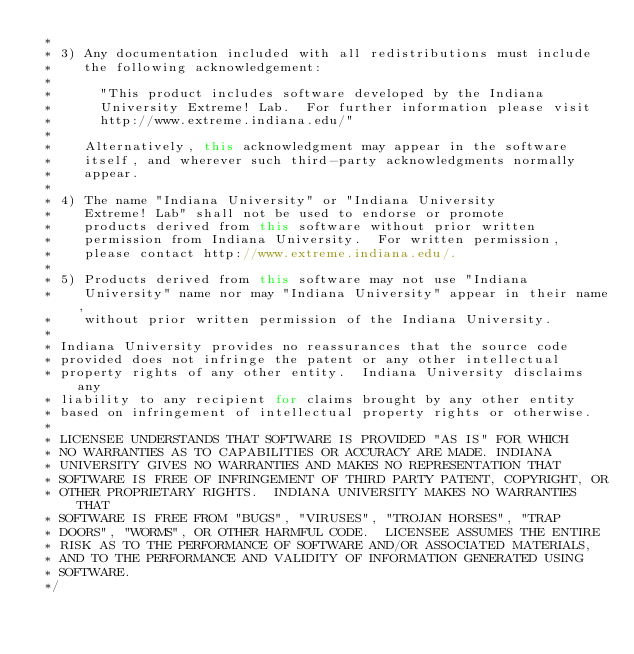Convert code to text. <code><loc_0><loc_0><loc_500><loc_500><_Java_> *
 * 3) Any documentation included with all redistributions must include
 *    the following acknowledgement:
 *
 *      "This product includes software developed by the Indiana
 *      University Extreme! Lab.  For further information please visit
 *      http://www.extreme.indiana.edu/"
 *
 *    Alternatively, this acknowledgment may appear in the software
 *    itself, and wherever such third-party acknowledgments normally
 *    appear.
 *
 * 4) The name "Indiana University" or "Indiana University
 *    Extreme! Lab" shall not be used to endorse or promote
 *    products derived from this software without prior written
 *    permission from Indiana University.  For written permission,
 *    please contact http://www.extreme.indiana.edu/.
 *
 * 5) Products derived from this software may not use "Indiana
 *    University" name nor may "Indiana University" appear in their name,
 *    without prior written permission of the Indiana University.
 *
 * Indiana University provides no reassurances that the source code
 * provided does not infringe the patent or any other intellectual
 * property rights of any other entity.  Indiana University disclaims any
 * liability to any recipient for claims brought by any other entity
 * based on infringement of intellectual property rights or otherwise.
 *
 * LICENSEE UNDERSTANDS THAT SOFTWARE IS PROVIDED "AS IS" FOR WHICH
 * NO WARRANTIES AS TO CAPABILITIES OR ACCURACY ARE MADE. INDIANA
 * UNIVERSITY GIVES NO WARRANTIES AND MAKES NO REPRESENTATION THAT
 * SOFTWARE IS FREE OF INFRINGEMENT OF THIRD PARTY PATENT, COPYRIGHT, OR
 * OTHER PROPRIETARY RIGHTS.  INDIANA UNIVERSITY MAKES NO WARRANTIES THAT
 * SOFTWARE IS FREE FROM "BUGS", "VIRUSES", "TROJAN HORSES", "TRAP
 * DOORS", "WORMS", OR OTHER HARMFUL CODE.  LICENSEE ASSUMES THE ENTIRE
 * RISK AS TO THE PERFORMANCE OF SOFTWARE AND/OR ASSOCIATED MATERIALS,
 * AND TO THE PERFORMANCE AND VALIDITY OF INFORMATION GENERATED USING
 * SOFTWARE.
 */

</code> 